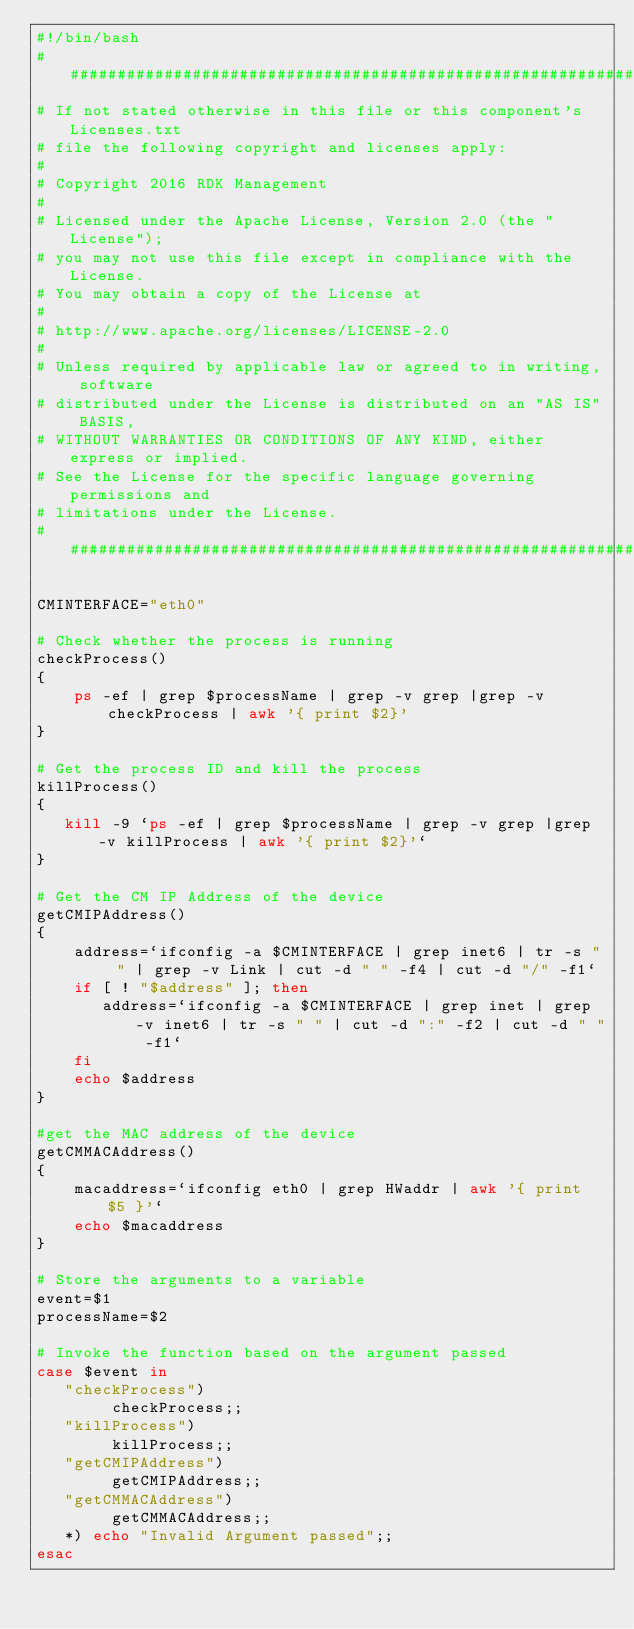<code> <loc_0><loc_0><loc_500><loc_500><_Bash_>#!/bin/bash
##########################################################################
# If not stated otherwise in this file or this component's Licenses.txt
# file the following copyright and licenses apply:
#
# Copyright 2016 RDK Management
#
# Licensed under the Apache License, Version 2.0 (the "License");
# you may not use this file except in compliance with the License.
# You may obtain a copy of the License at
#
# http://www.apache.org/licenses/LICENSE-2.0
#
# Unless required by applicable law or agreed to in writing, software
# distributed under the License is distributed on an "AS IS" BASIS,
# WITHOUT WARRANTIES OR CONDITIONS OF ANY KIND, either express or implied.
# See the License for the specific language governing permissions and
# limitations under the License.
##########################################################################

CMINTERFACE="eth0"

# Check whether the process is running
checkProcess()
{
    ps -ef | grep $processName | grep -v grep |grep -v checkProcess | awk '{ print $2}'
}

# Get the process ID and kill the process
killProcess()
{
   kill -9 `ps -ef | grep $processName | grep -v grep |grep -v killProcess | awk '{ print $2}'`
}

# Get the CM IP Address of the device
getCMIPAddress()
{
    address=`ifconfig -a $CMINTERFACE | grep inet6 | tr -s " " | grep -v Link | cut -d " " -f4 | cut -d "/" -f1`
    if [ ! "$address" ]; then
       address=`ifconfig -a $CMINTERFACE | grep inet | grep -v inet6 | tr -s " " | cut -d ":" -f2 | cut -d " " -f1`
    fi
    echo $address
}

#get the MAC address of the device
getCMMACAddress()
{
    macaddress=`ifconfig eth0 | grep HWaddr | awk '{ print $5 }'`
    echo $macaddress
}

# Store the arguments to a variable
event=$1
processName=$2

# Invoke the function based on the argument passed
case $event in
   "checkProcess")
        checkProcess;;
   "killProcess")
        killProcess;;
   "getCMIPAddress")
        getCMIPAddress;;
   "getCMMACAddress")
        getCMMACAddress;;
   *) echo "Invalid Argument passed";;
esac
</code> 